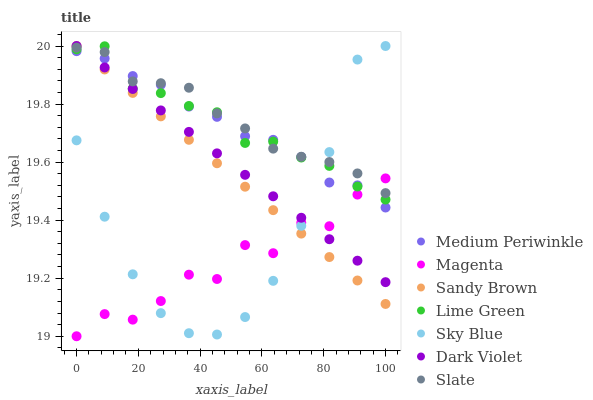Does Magenta have the minimum area under the curve?
Answer yes or no. Yes. Does Slate have the maximum area under the curve?
Answer yes or no. Yes. Does Medium Periwinkle have the minimum area under the curve?
Answer yes or no. No. Does Medium Periwinkle have the maximum area under the curve?
Answer yes or no. No. Is Sandy Brown the smoothest?
Answer yes or no. Yes. Is Magenta the roughest?
Answer yes or no. Yes. Is Slate the smoothest?
Answer yes or no. No. Is Slate the roughest?
Answer yes or no. No. Does Magenta have the lowest value?
Answer yes or no. Yes. Does Medium Periwinkle have the lowest value?
Answer yes or no. No. Does Sandy Brown have the highest value?
Answer yes or no. Yes. Does Slate have the highest value?
Answer yes or no. No. Does Lime Green intersect Sandy Brown?
Answer yes or no. Yes. Is Lime Green less than Sandy Brown?
Answer yes or no. No. Is Lime Green greater than Sandy Brown?
Answer yes or no. No. 